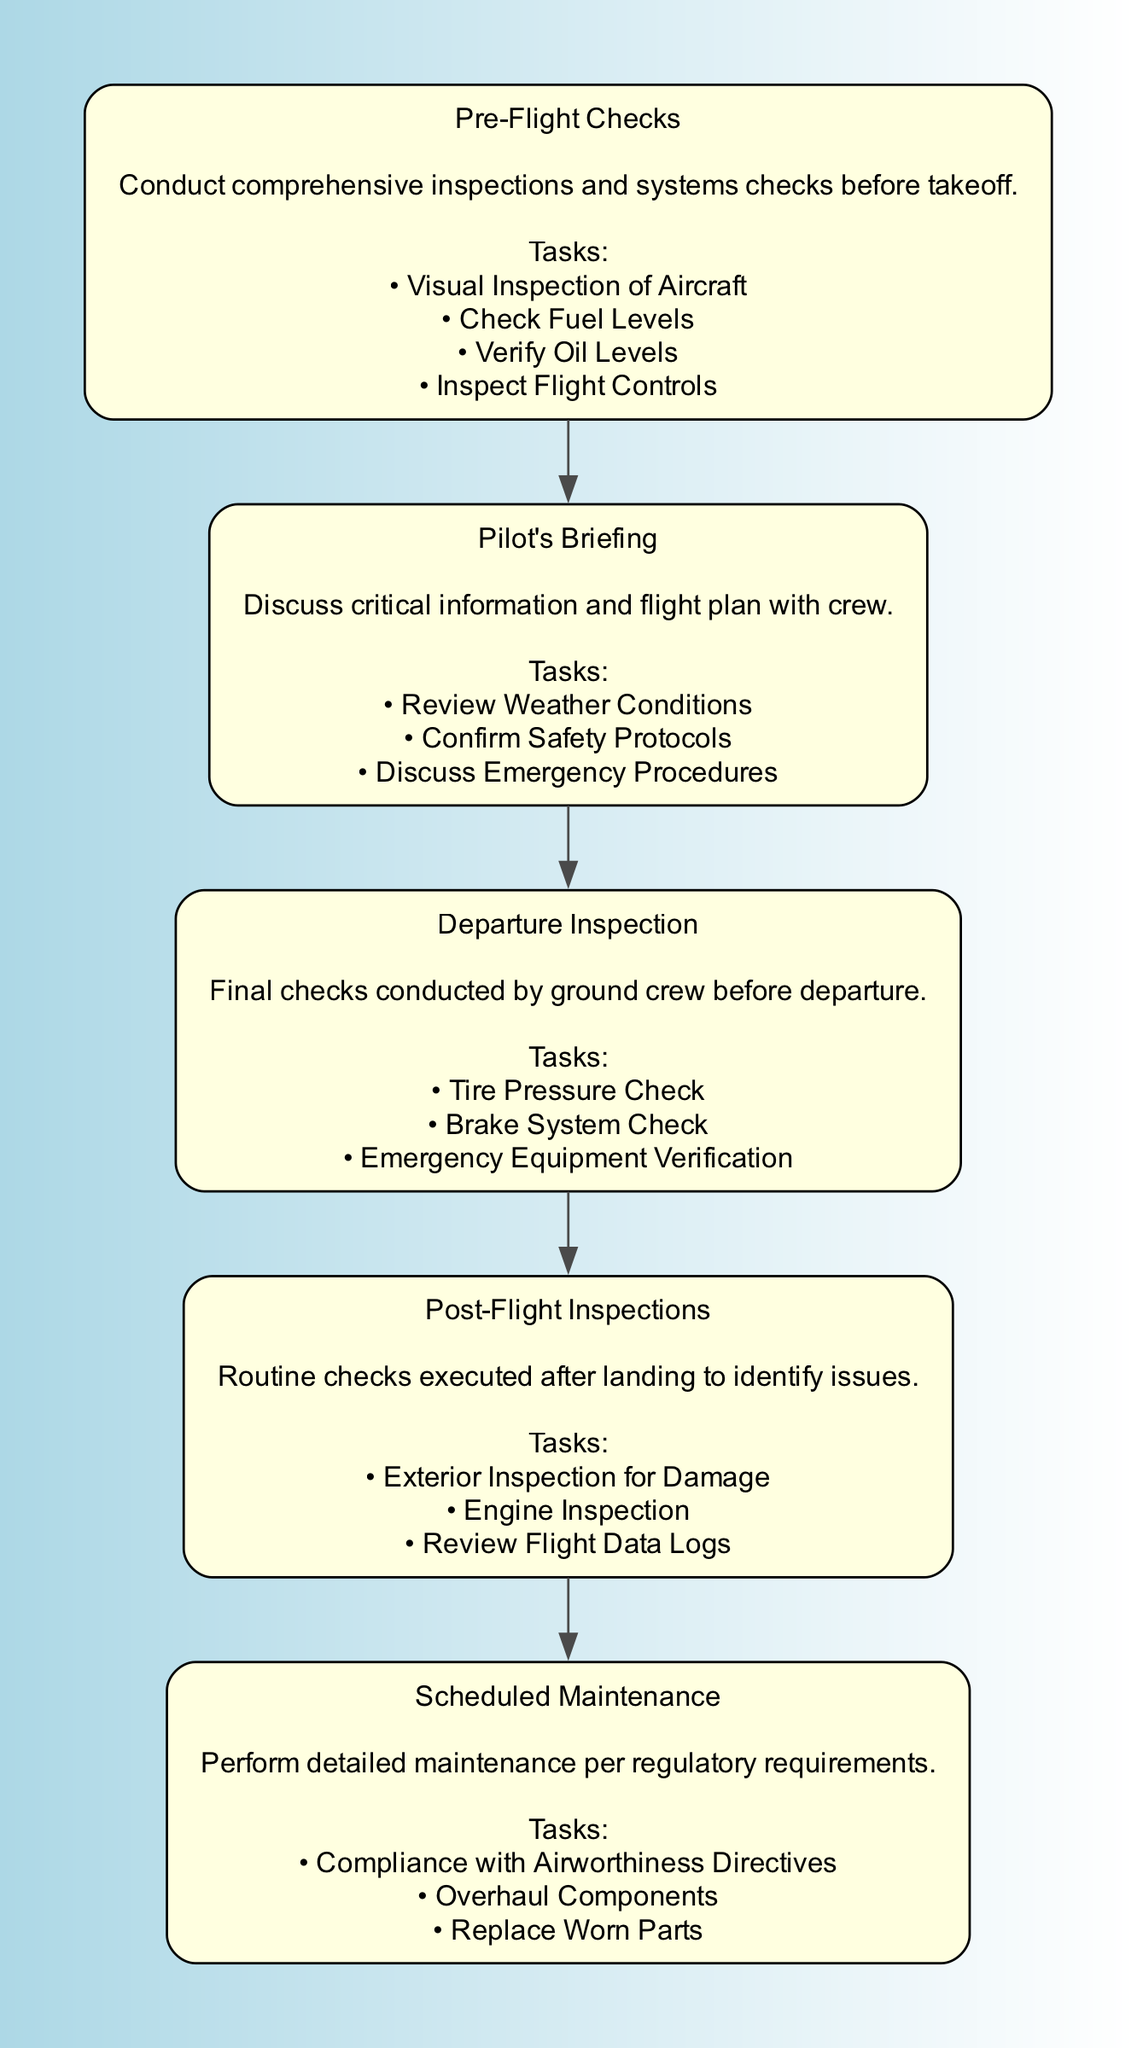What is the first step in the aircraft maintenance process? The first step listed in the flow chart is "Pre-Flight Checks." This is determined by examining the order of elements from top to bottom.
Answer: Pre-Flight Checks How many total tasks are listed in the Departure Inspection step? The Departure Inspection step includes three specific tasks: Tire Pressure Check, Brake System Check, and Emergency Equipment Verification. Counting these gives us a total of three tasks.
Answer: 3 What describes the Scheduled Maintenance step? The step "Scheduled Maintenance" is described as "Perform detailed maintenance per regulatory requirements." This is the descriptive information provided directly under the Scheduled Maintenance node.
Answer: Perform detailed maintenance per regulatory requirements Which step involves reviewing weather conditions? The step that includes reviewing weather conditions is "Pilot's Briefing." This information comes from the tasks enumerated under the Pilot's Briefing node.
Answer: Pilot's Briefing What is the relationship between Post-Flight Inspections and Scheduled Maintenance? Post-Flight Inspections and Scheduled Maintenance are sequential in the flow chart, meaning Post-Flight Inspections occur before Scheduled Maintenance. This can be inferred from their arrangement in the flow chart, where Scheduled Maintenance follows Post-Flight Inspections.
Answer: Post-Flight Inspections precedes Scheduled Maintenance How many nodes are there in total in this flow chart? There are five distinct steps (nodes) in the flow chart: Pre-Flight Checks, Pilot's Briefing, Departure Inspection, Post-Flight Inspections, and Scheduled Maintenance. Counting each of these steps provides the total number of nodes.
Answer: 5 What is the last task mentioned in the Post-Flight Inspections step? The last task listed in the Post-Flight Inspections step is "Review Flight Data Logs." This is determined by inspecting the list of tasks in the Post-Flight Inspections node.
Answer: Review Flight Data Logs What information is discussed during the Pilot's Briefing? During the Pilot's Briefing, the crew discusses critical information such as Weather Conditions, Safety Protocols, and Emergency Procedures. These specific points are detailed in the tasks section under the Pilot's Briefing node.
Answer: Weather Conditions, Safety Protocols, and Emergency Procedures 